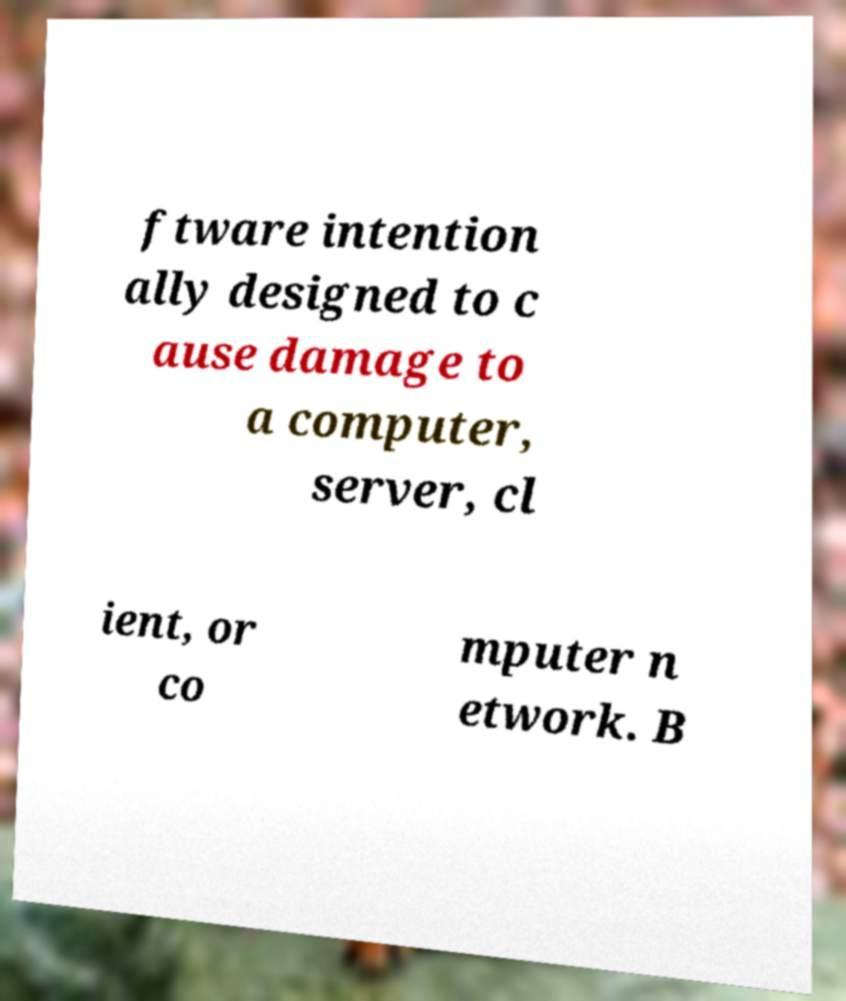For documentation purposes, I need the text within this image transcribed. Could you provide that? ftware intention ally designed to c ause damage to a computer, server, cl ient, or co mputer n etwork. B 